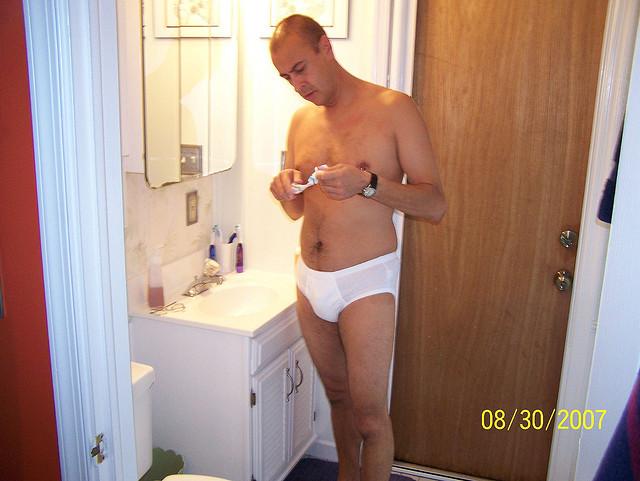Would these underwear be considered "tighty whities"?
Write a very short answer. Yes. What is the man wearing?
Concise answer only. Underwear. Where is this picture taken?
Keep it brief. Bathroom. What color is the trash can?
Keep it brief. Green. 